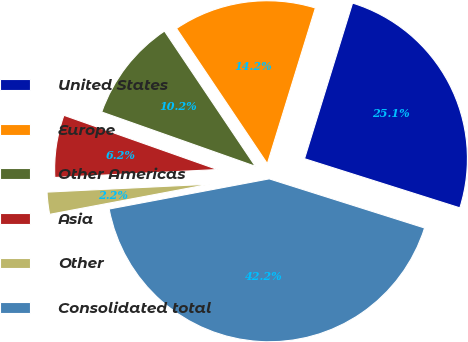Convert chart to OTSL. <chart><loc_0><loc_0><loc_500><loc_500><pie_chart><fcel>United States<fcel>Europe<fcel>Other Americas<fcel>Asia<fcel>Other<fcel>Consolidated total<nl><fcel>25.11%<fcel>14.18%<fcel>10.18%<fcel>6.18%<fcel>2.19%<fcel>42.16%<nl></chart> 